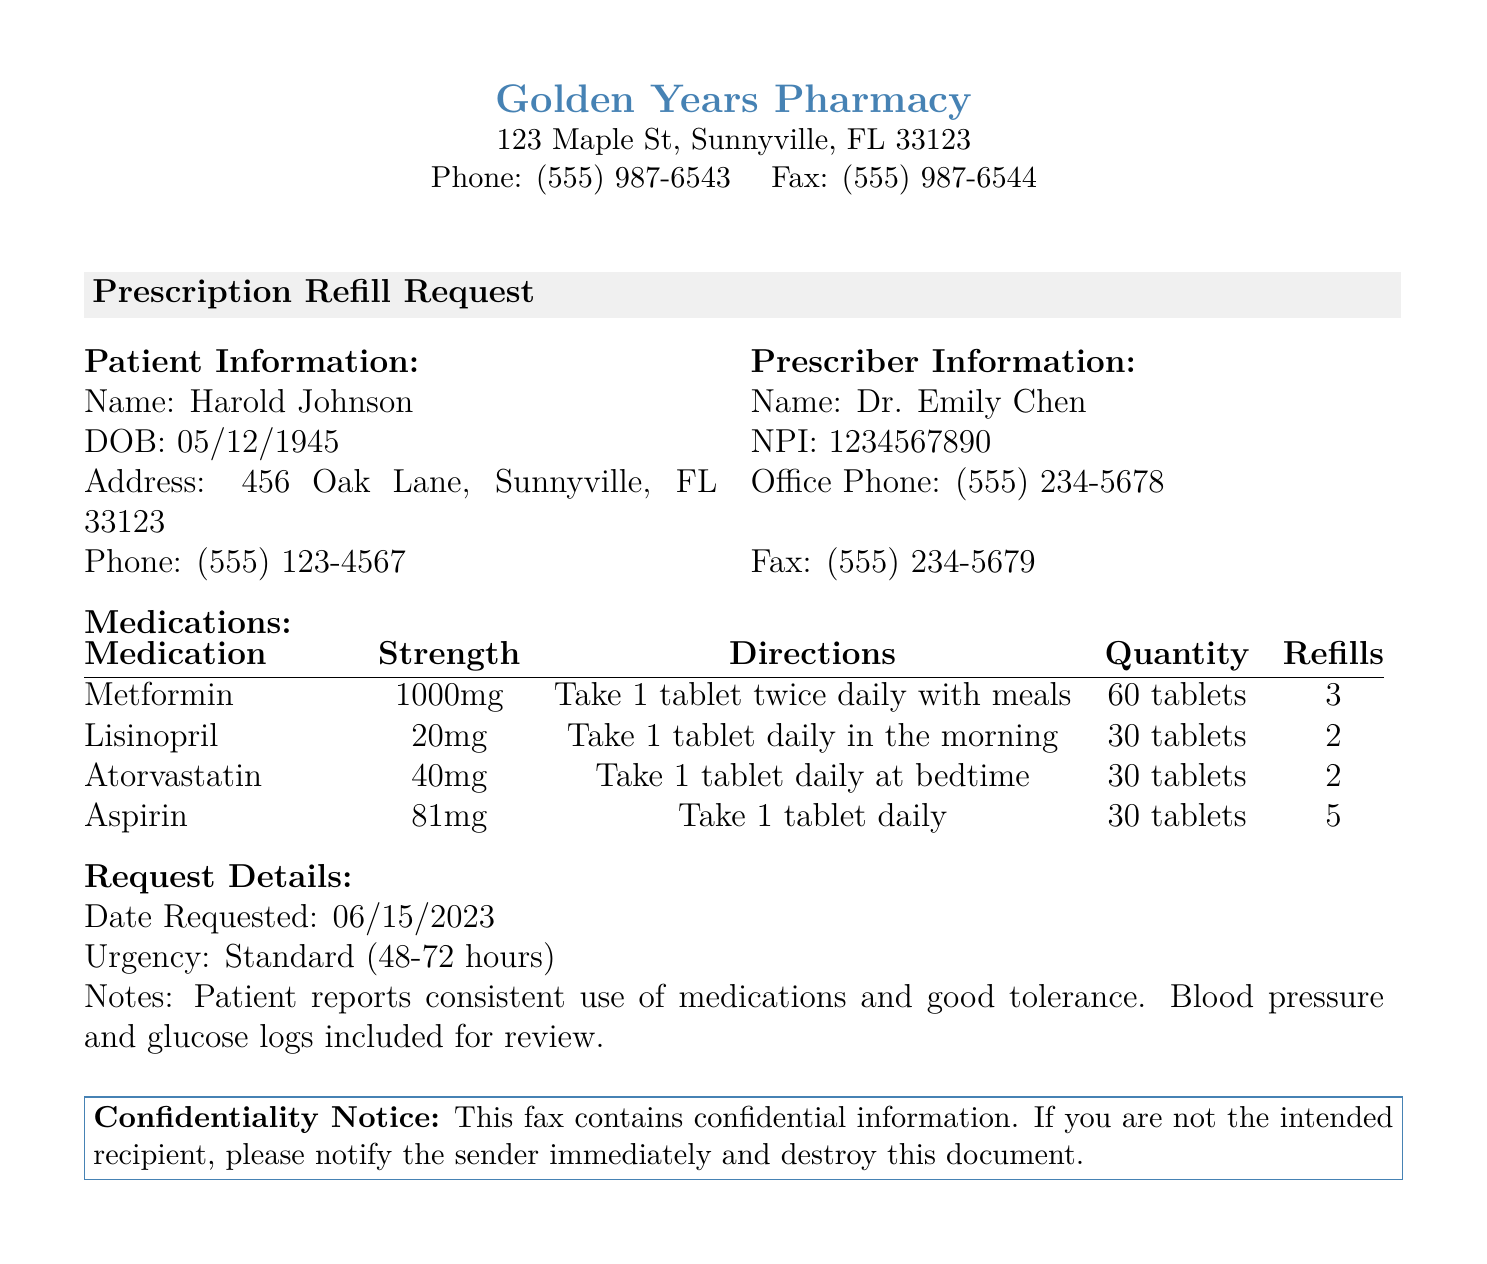What is the patient's name? The document states the patient's name in the Patient Information section, which is Harold Johnson.
Answer: Harold Johnson What is the strength of Lisinopril? The strength of Lisinopril is listed in the Medications section next to the medication name.
Answer: 20mg When was the prescription refill requested? The date requested is mentioned in the Request Details section, indicating when the request was made.
Answer: 06/15/2023 How many refills are available for Atorvastatin? The number of refills available is specified in the Medications table under the Refills column for Atorvastatin.
Answer: 2 What is the urgency of the refill request? The urgency of the request is included in the Request Details section, specifying how quickly the refill is needed.
Answer: Standard (48-72 hours) What is the patient's date of birth? The patient's date of birth is provided in the Patient Information section of the document.
Answer: 05/12/1945 How many tablets of Aspirin are requested? The quantity of Aspirin requested is clearly indicated in the Medications table under the Quantity column.
Answer: 30 tablets Who is the prescriber of the medications? The prescriber's name is found in the Prescriber Information section, indicating the healthcare provider responsible for the prescriptions.
Answer: Dr. Emily Chen What is the office phone number of the prescriber? The office phone number is provided in the Prescriber Information section of the document.
Answer: (555) 234-5678 